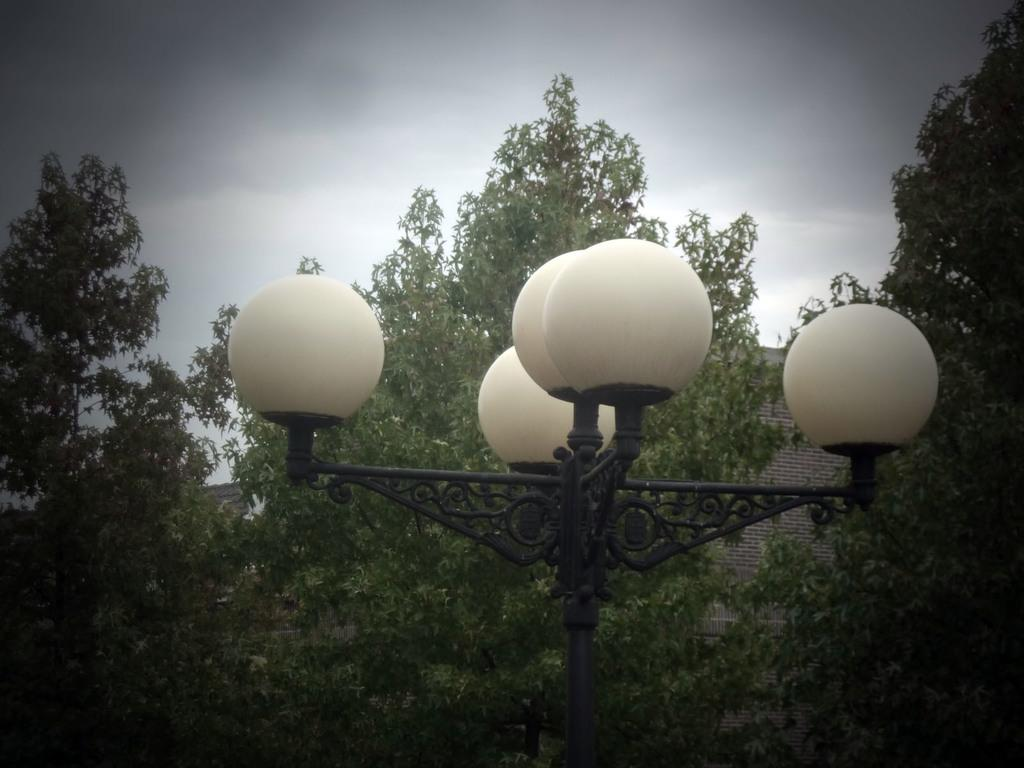What is the main object in the foreground of the image? There is a pole with lights in the image. What can be seen in the background of the image? There are trees and a building in the background of the image. What is visible at the top of the image? The sky is visible at the top of the image. What type of cream can be seen on the teeth of the person in the image? There is no person present in the image, and therefore no teeth or cream can be observed. How many tomatoes are visible on the pole with lights in the image? There are no tomatoes present on the pole with lights in the image. 